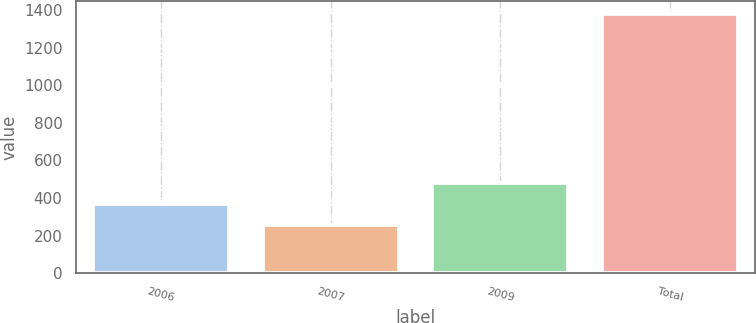<chart> <loc_0><loc_0><loc_500><loc_500><bar_chart><fcel>2006<fcel>2007<fcel>2009<fcel>Total<nl><fcel>366.8<fcel>254<fcel>479.6<fcel>1382<nl></chart> 